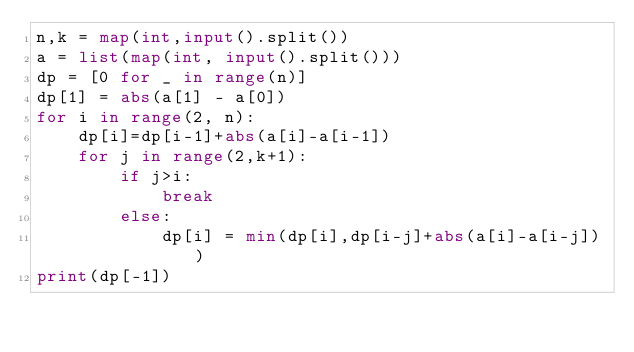Convert code to text. <code><loc_0><loc_0><loc_500><loc_500><_Python_>n,k = map(int,input().split())
a = list(map(int, input().split()))
dp = [0 for _ in range(n)]
dp[1] = abs(a[1] - a[0])
for i in range(2, n):
    dp[i]=dp[i-1]+abs(a[i]-a[i-1])
    for j in range(2,k+1):
        if j>i:
            break
        else:
            dp[i] = min(dp[i],dp[i-j]+abs(a[i]-a[i-j]))
print(dp[-1])</code> 